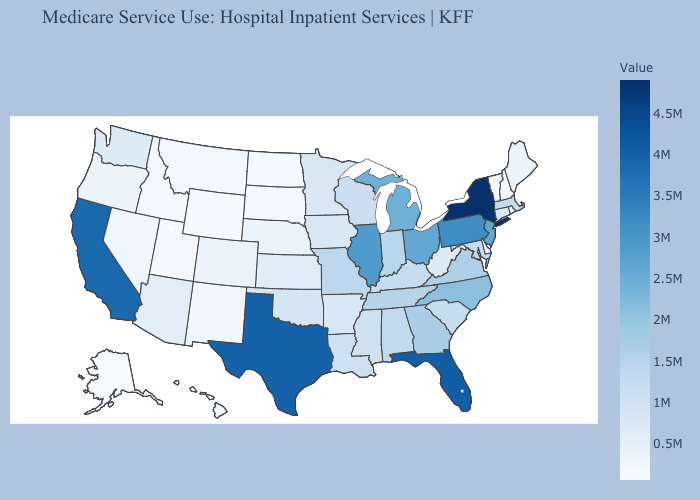Among the states that border Virginia , does Kentucky have the lowest value?
Keep it brief. No. Which states hav the highest value in the MidWest?
Be succinct. Illinois. Is the legend a continuous bar?
Short answer required. Yes. Among the states that border Minnesota , does Wisconsin have the highest value?
Write a very short answer. Yes. Does New York have the highest value in the Northeast?
Answer briefly. Yes. Does the map have missing data?
Short answer required. No. Does Connecticut have a higher value than Ohio?
Write a very short answer. No. Does New York have the highest value in the USA?
Concise answer only. Yes. 